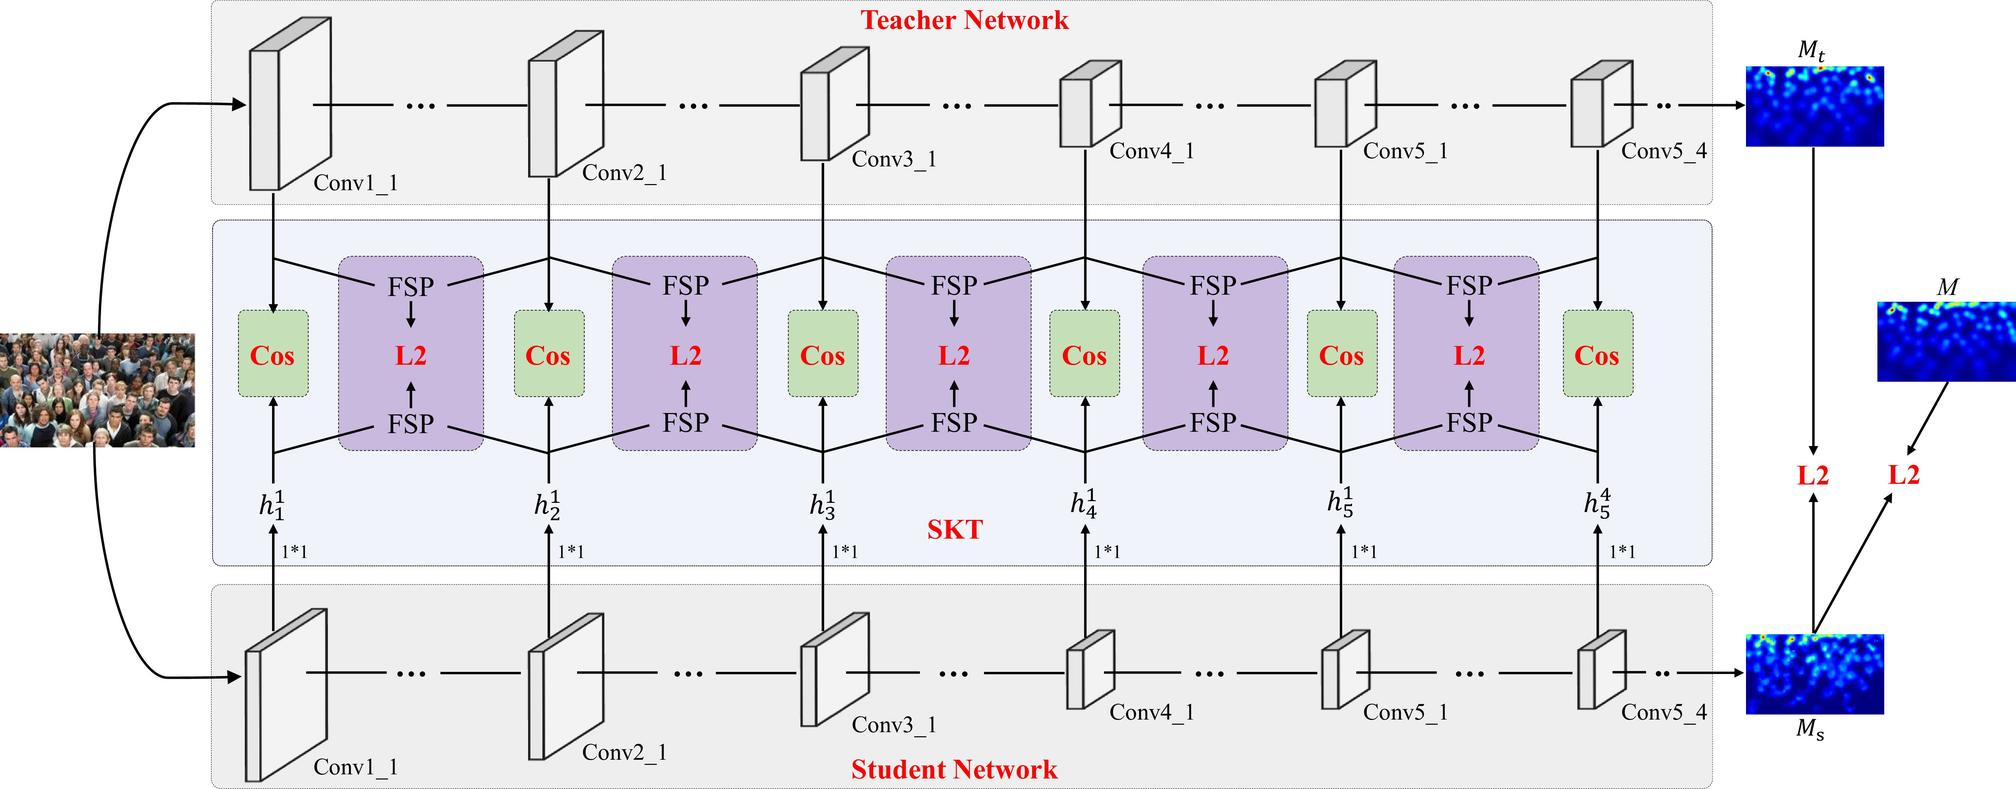How do the 'Cos' and 'L2' blocks contribute to the learning process illustrated here? In this diagram, 'Cos' refers to the cosine similarity metric, and 'L2' likely refers to the L2 norm or Euclidean distance. These blocks are used to calculate the similarity or difference between the feature maps produced by the student and teacher networks at corresponding layers. The 'Cos' blocks measure the cosine similarity between the teacher's and student's feature maps—values closer to 1 indicate more similarity. This metric focuses on the angle between feature vectors, essentially comparing the direction of the data patterns regardless of their magnitude. The 'L2' blocks compute the L2 norm to measure the Euclidean distance between the teacher's and student's feature maps—the lower the value, the closer and more similar the feature maps. Both metrics are instrumental for the optimization process, driving the student network to learn features that are directionally aligned and closely matched in magnitude with the teacher's, all part of the knowledge distillation process to improve the student network's performance while maintaining a smaller and more efficient architecture. 